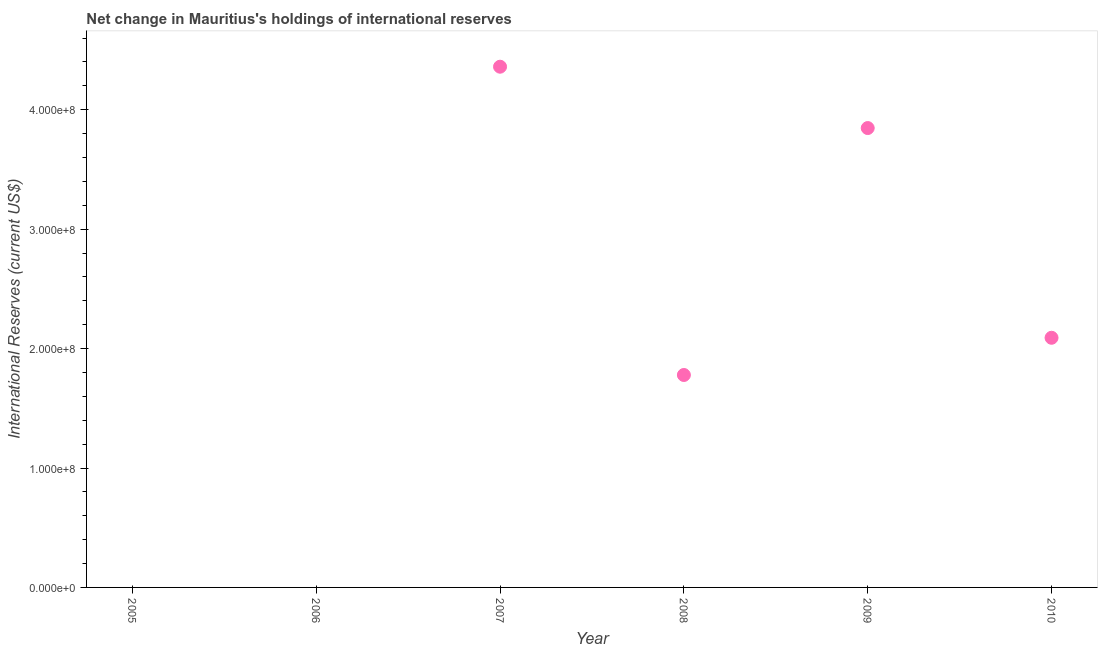What is the reserves and related items in 2009?
Keep it short and to the point. 3.85e+08. Across all years, what is the maximum reserves and related items?
Your answer should be compact. 4.36e+08. Across all years, what is the minimum reserves and related items?
Offer a terse response. 0. What is the sum of the reserves and related items?
Your answer should be compact. 1.21e+09. What is the difference between the reserves and related items in 2009 and 2010?
Give a very brief answer. 1.76e+08. What is the average reserves and related items per year?
Keep it short and to the point. 2.01e+08. What is the median reserves and related items?
Make the answer very short. 1.93e+08. What is the ratio of the reserves and related items in 2007 to that in 2009?
Offer a very short reply. 1.13. Is the reserves and related items in 2007 less than that in 2010?
Provide a succinct answer. No. What is the difference between the highest and the second highest reserves and related items?
Provide a succinct answer. 5.14e+07. What is the difference between the highest and the lowest reserves and related items?
Make the answer very short. 4.36e+08. In how many years, is the reserves and related items greater than the average reserves and related items taken over all years?
Your answer should be very brief. 3. Does the reserves and related items monotonically increase over the years?
Offer a very short reply. No. How many dotlines are there?
Offer a very short reply. 1. Are the values on the major ticks of Y-axis written in scientific E-notation?
Offer a very short reply. Yes. Does the graph contain grids?
Provide a succinct answer. No. What is the title of the graph?
Provide a succinct answer. Net change in Mauritius's holdings of international reserves. What is the label or title of the Y-axis?
Your answer should be very brief. International Reserves (current US$). What is the International Reserves (current US$) in 2005?
Give a very brief answer. 0. What is the International Reserves (current US$) in 2006?
Your response must be concise. 0. What is the International Reserves (current US$) in 2007?
Ensure brevity in your answer.  4.36e+08. What is the International Reserves (current US$) in 2008?
Your answer should be compact. 1.78e+08. What is the International Reserves (current US$) in 2009?
Your response must be concise. 3.85e+08. What is the International Reserves (current US$) in 2010?
Make the answer very short. 2.09e+08. What is the difference between the International Reserves (current US$) in 2007 and 2008?
Ensure brevity in your answer.  2.58e+08. What is the difference between the International Reserves (current US$) in 2007 and 2009?
Ensure brevity in your answer.  5.14e+07. What is the difference between the International Reserves (current US$) in 2007 and 2010?
Provide a succinct answer. 2.27e+08. What is the difference between the International Reserves (current US$) in 2008 and 2009?
Your response must be concise. -2.07e+08. What is the difference between the International Reserves (current US$) in 2008 and 2010?
Offer a terse response. -3.12e+07. What is the difference between the International Reserves (current US$) in 2009 and 2010?
Make the answer very short. 1.76e+08. What is the ratio of the International Reserves (current US$) in 2007 to that in 2008?
Provide a succinct answer. 2.45. What is the ratio of the International Reserves (current US$) in 2007 to that in 2009?
Offer a terse response. 1.13. What is the ratio of the International Reserves (current US$) in 2007 to that in 2010?
Provide a succinct answer. 2.09. What is the ratio of the International Reserves (current US$) in 2008 to that in 2009?
Provide a succinct answer. 0.46. What is the ratio of the International Reserves (current US$) in 2008 to that in 2010?
Make the answer very short. 0.85. What is the ratio of the International Reserves (current US$) in 2009 to that in 2010?
Make the answer very short. 1.84. 